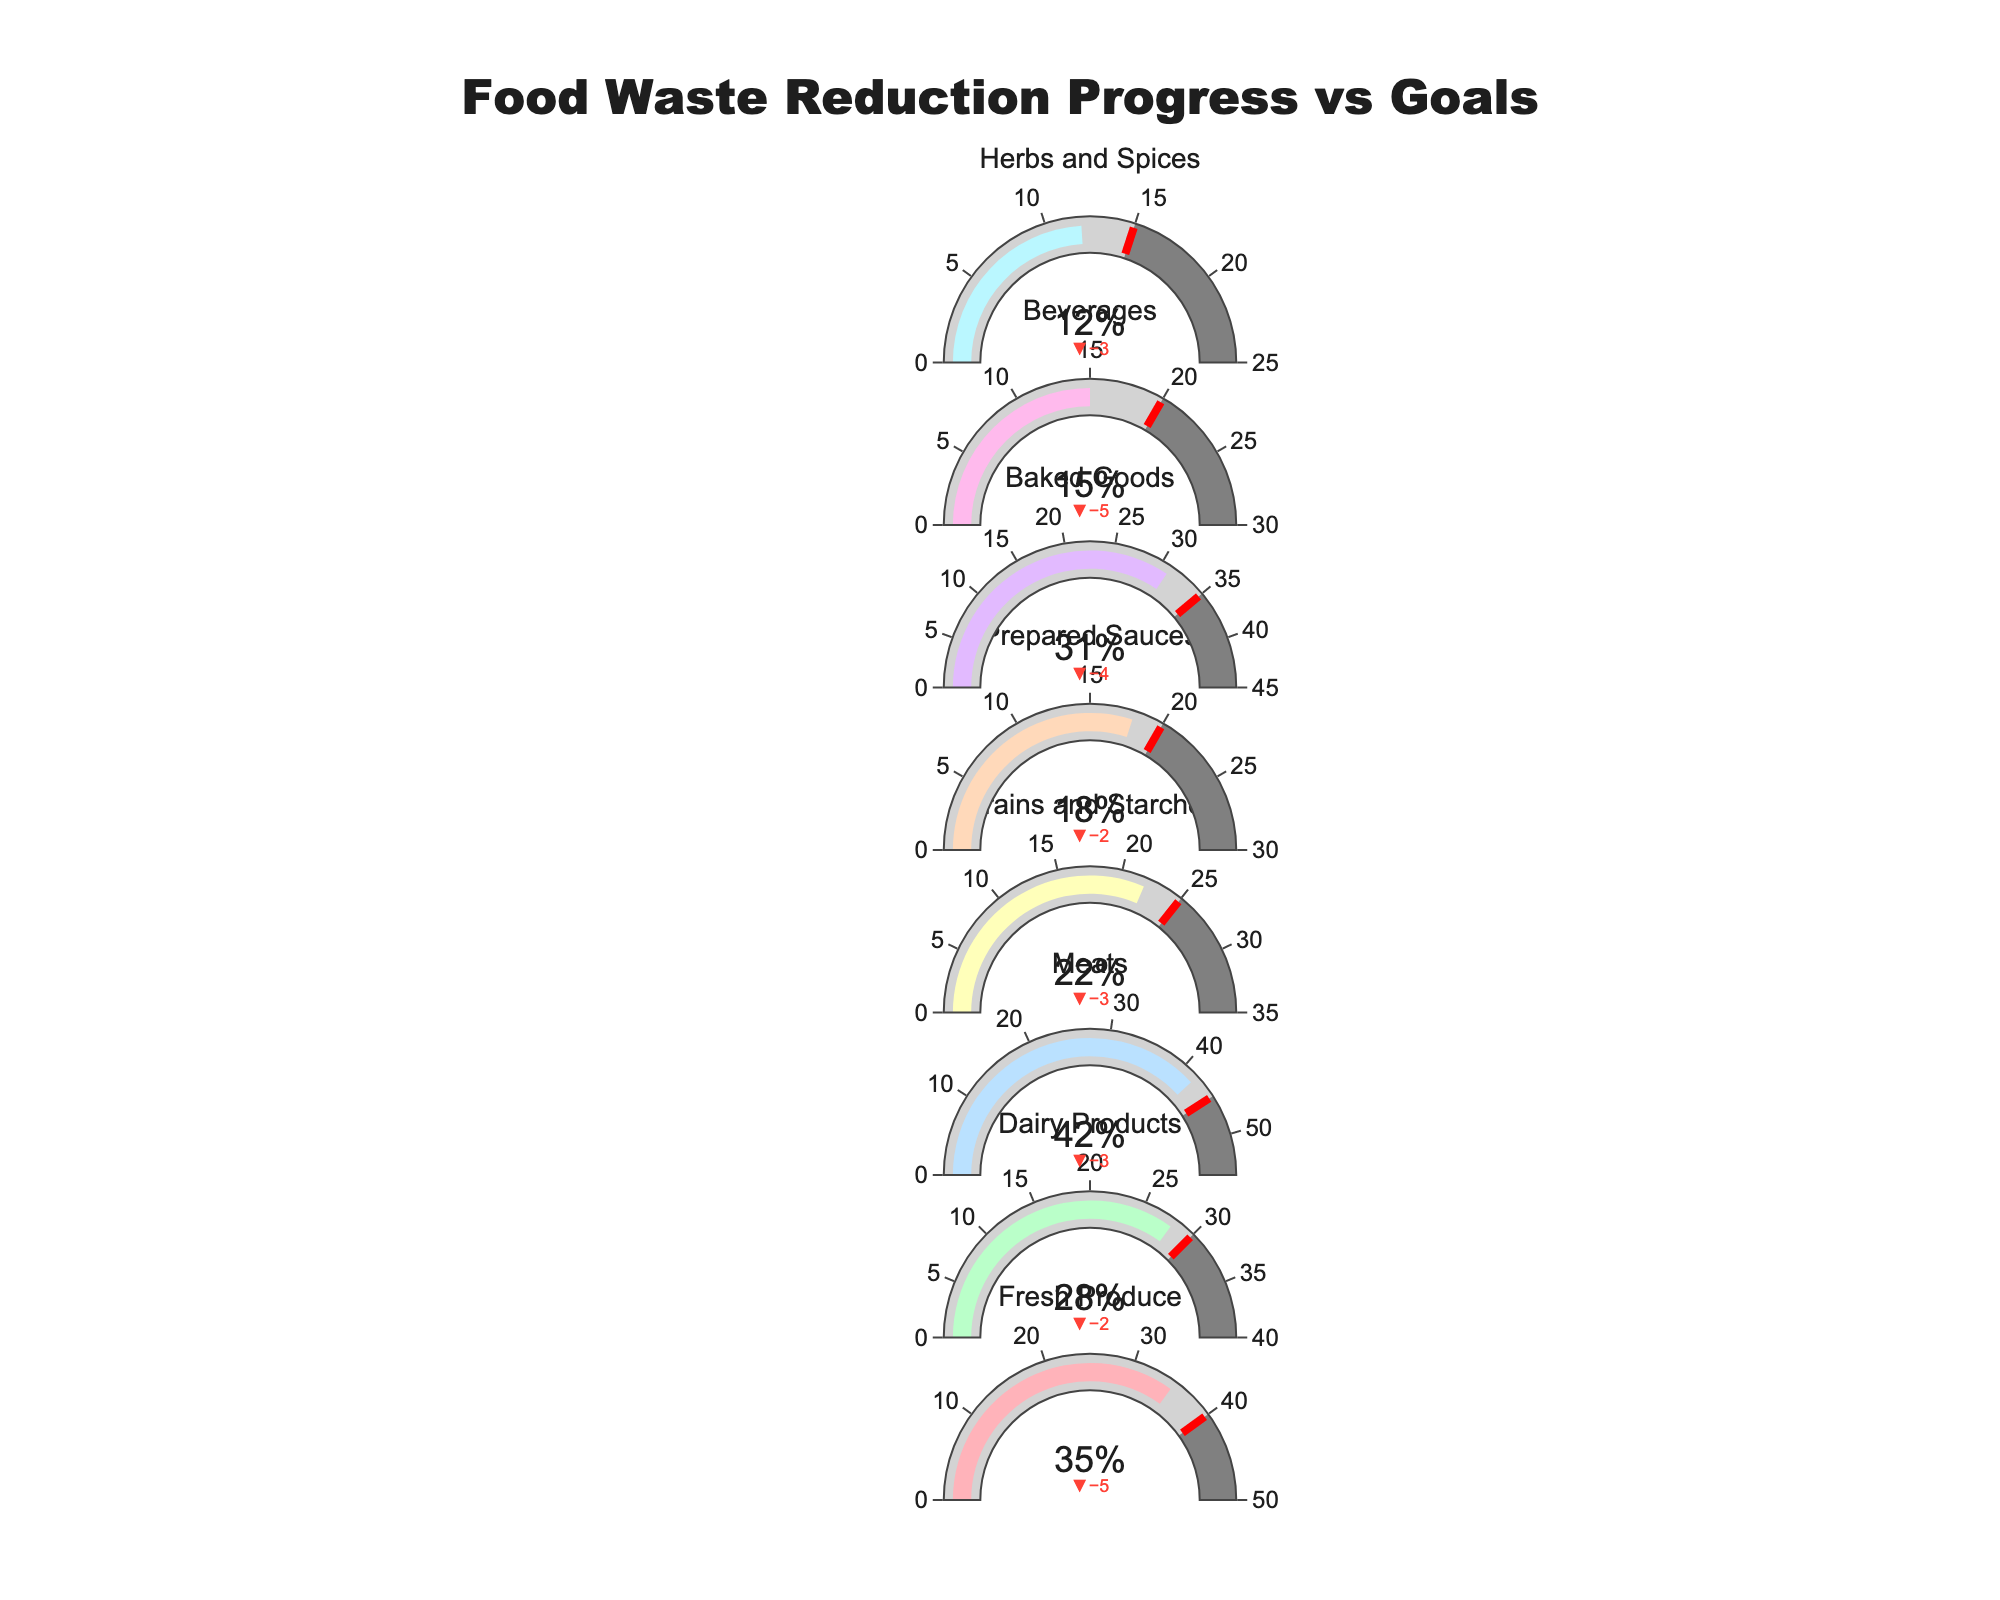What is the title of the figure? The title of the figure is located at the top, centered and highlighted in a larger font to capture attention. It is crucial as it provides the viewer with a summary of the content in the chart.
Answer: Food Waste Reduction Progress vs Goals Which ingredient has the highest actual reduction percentage? To find the ingredient with the highest actual reduction percentage, look at each gauge bar and identify the one with the highest value.
Answer: Meats What is the target reduction percentage for Fresh Produce? Locate the section for "Fresh Produce" and observe the indicator for the target reduction percentage, which is visually represented by a threshold in the gauge.
Answer: 40% How much does the actual reduction percentage for Baked Goods differ from its target reduction percentage? Subtract the target reduction percentage for Baked Goods from its actual reduction percentage: 31 - 35 = -4. This shows a negative difference indicating it has not met its target.
Answer: -4% Which ingredient has the smallest actual reduction percentage? Sort through all the actual reduction values displayed on the gauges and identify the smallest value.
Answer: Herbs and Spices Have any ingredients achieved or exceeded their target reduction percentage? Compare the actual reduction percentage to the target reduction percentage for each ingredient. If any actual values are equal to or greater than the target values, those have achieved or exceeded their targets.
Answer: No What is the range of reduction percentages shown for Grains and Starches? The range is the interval between the minimum value (0) and the maximum reduction goal indicated on the gauge for Grains and Starches, which can be read directly from its gauge.
Answer: 0% to 35% Which ingredient shows the largest difference between target and maximum reduction goal percentages? Calculate the difference for each ingredient by subtracting the target reduction percentage from the maximum reduction goal percentage, then identify which ingredient has the largest value.
Answer: Meats (10%) Which ingredients have an actual reduction percentage below 20%? Identify the gauge bars where the actual reduction percentage is below 20%.
Answer: Prepared Sauces, Beverages, Herbs and Spices What color is used to indicate the completion of the actual reduction percentage for Dairy Products? Identify the color of the bar that shows the actual reduction percentage completion for Dairy Products.
Answer: Light Green 